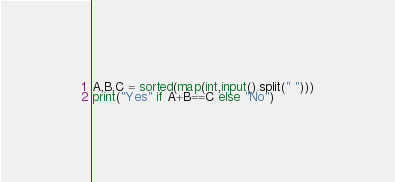Convert code to text. <code><loc_0><loc_0><loc_500><loc_500><_Python_>A,B,C = sorted(map(int,input().split(" ")))
print("Yes" if A+B==C else "No")</code> 